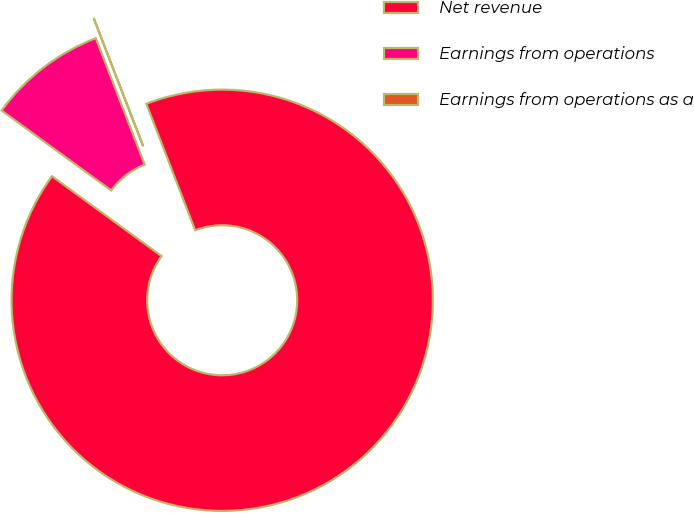Convert chart to OTSL. <chart><loc_0><loc_0><loc_500><loc_500><pie_chart><fcel>Net revenue<fcel>Earnings from operations<fcel>Earnings from operations as a<nl><fcel>90.88%<fcel>9.1%<fcel>0.01%<nl></chart> 